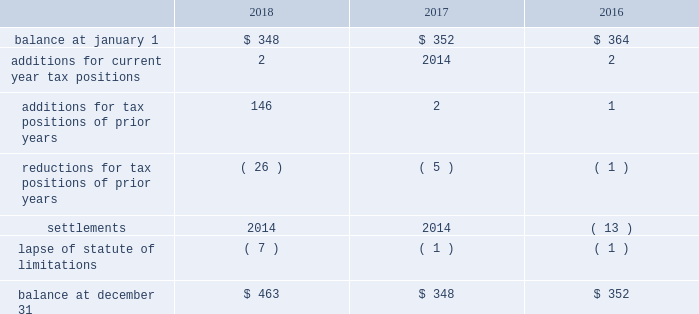The aes corporation notes to consolidated financial statements 2014 ( continued ) december 31 , 2018 , 2017 , and 2016 the following is a reconciliation of the beginning and ending amounts of unrecognized tax benefits for the periods indicated ( in millions ) : .
The company and certain of its subsidiaries are currently under examination by the relevant taxing authorities for various tax years .
The company regularly assesses the potential outcome of these examinations in each of the taxing jurisdictions when determining the adequacy of the amount of unrecognized tax benefit recorded .
While it is often difficult to predict the final outcome or the timing of resolution of any particular uncertain tax position , we believe we have appropriately accrued for our uncertain tax benefits .
However , audit outcomes and the timing of audit settlements and future events that would impact our previously recorded unrecognized tax benefits and the range of anticipated increases or decreases in unrecognized tax benefits are subject to significant uncertainty .
It is possible that the ultimate outcome of current or future examinations may exceed our provision for current unrecognized tax benefits in amounts that could be material , but cannot be estimated as of december 31 , 2018 .
Our effective tax rate and net income in any given future period could therefore be materially impacted .
22 .
Discontinued operations due to a portfolio evaluation in the first half of 2016 , management decided to pursue a strategic shift of its distribution companies in brazil , sul and eletropaulo , to reduce the company's exposure to the brazilian distribution market .
The disposals of sul and eletropaulo were completed in october 2016 and june 2018 , respectively .
Eletropaulo 2014 in november 2017 , eletropaulo converted its preferred shares into ordinary shares and transitioned the listing of those shares to the novo mercado , which is a listing segment of the brazilian stock exchange with the highest standards of corporate governance .
Upon conversion of the preferred shares into ordinary shares , aes no longer controlled eletropaulo , but maintained significant influence over the business .
As a result , the company deconsolidated eletropaulo .
After deconsolidation , the company's 17% ( 17 % ) ownership interest was reflected as an equity method investment .
The company recorded an after-tax loss on deconsolidation of $ 611 million , which primarily consisted of $ 455 million related to cumulative translation losses and $ 243 million related to pension losses reclassified from aocl .
In december 2017 , all the remaining criteria were met for eletropaulo to qualify as a discontinued operation .
Therefore , its results of operations and financial position were reported as such in the consolidated financial statements for all periods presented .
In june 2018 , the company completed the sale of its entire 17% ( 17 % ) ownership interest in eletropaulo through a bidding process hosted by the brazilian securities regulator , cvm .
Gross proceeds of $ 340 million were received at our subsidiary in brazil , subject to the payment of taxes .
Upon disposal of eletropaulo , the company recorded a pre-tax gain on sale of $ 243 million ( after-tax $ 199 million ) .
Excluding the gain on sale , eletropaulo's pre-tax loss attributable to aes was immaterial for the year ended december 31 , 2018 .
Eletropaulo's pre-tax loss attributable to aes , including the loss on deconsolidation , for the years ended december 31 , 2017 and 2016 was $ 633 million and $ 192 million , respectively .
Prior to its classification as discontinued operations , eletropaulo was reported in the south america sbu reportable segment .
Sul 2014 the company executed an agreement for the sale of sul , a wholly-owned subsidiary , in june 2016 .
The results of operations and financial position of sul are reported as discontinued operations in the consolidated financial statements for all periods presented .
Upon meeting the held-for-sale criteria , the company recognized an after-tax loss of $ 382 million comprised of a pre-tax impairment charge of $ 783 million , offset by a tax benefit of $ 266 million related to the impairment of the sul long lived assets and a tax benefit of $ 135 million for deferred taxes related to the investment in sul .
Prior to the impairment charge , the carrying value of the sul asset group of $ 1.6 billion was greater than its approximate fair value less costs to sell .
However , the impairment charge was limited to the carrying value of the long lived assets of the sul disposal group. .
What was the implied value as of june 2018 for eletropaulo , in millions? 
Computations: (340 / 17%)
Answer: 2000.0. 